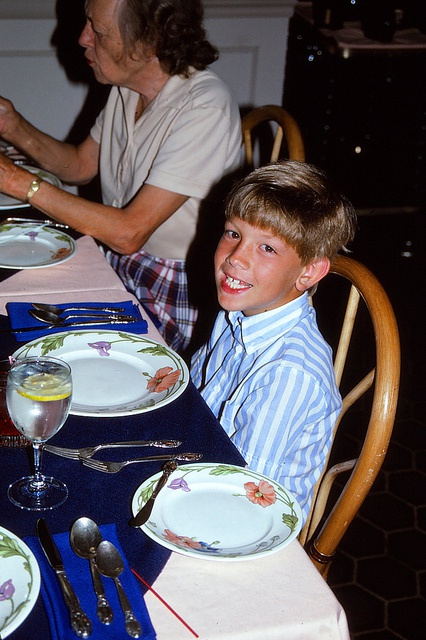Describe the objects in this image and their specific colors. I can see dining table in black, lightgray, darkgray, and navy tones, people in black, darkgray, brown, and gray tones, people in black and lightblue tones, chair in black, brown, maroon, and tan tones, and wine glass in black, gray, darkgray, and lightblue tones in this image. 